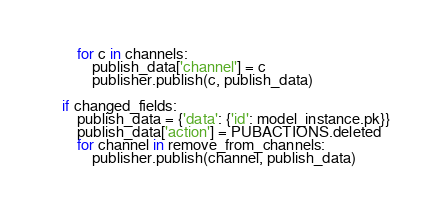Convert code to text. <code><loc_0><loc_0><loc_500><loc_500><_Python_>
        for c in channels:
            publish_data['channel'] = c
            publisher.publish(c, publish_data)

    if changed_fields:
        publish_data = {'data': {'id': model_instance.pk}}
        publish_data['action'] = PUBACTIONS.deleted
        for channel in remove_from_channels:
            publisher.publish(channel, publish_data)
</code> 